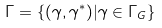Convert formula to latex. <formula><loc_0><loc_0><loc_500><loc_500>\Gamma = \{ ( \gamma , \gamma ^ { * } ) | \gamma \in \Gamma _ { G } \}</formula> 